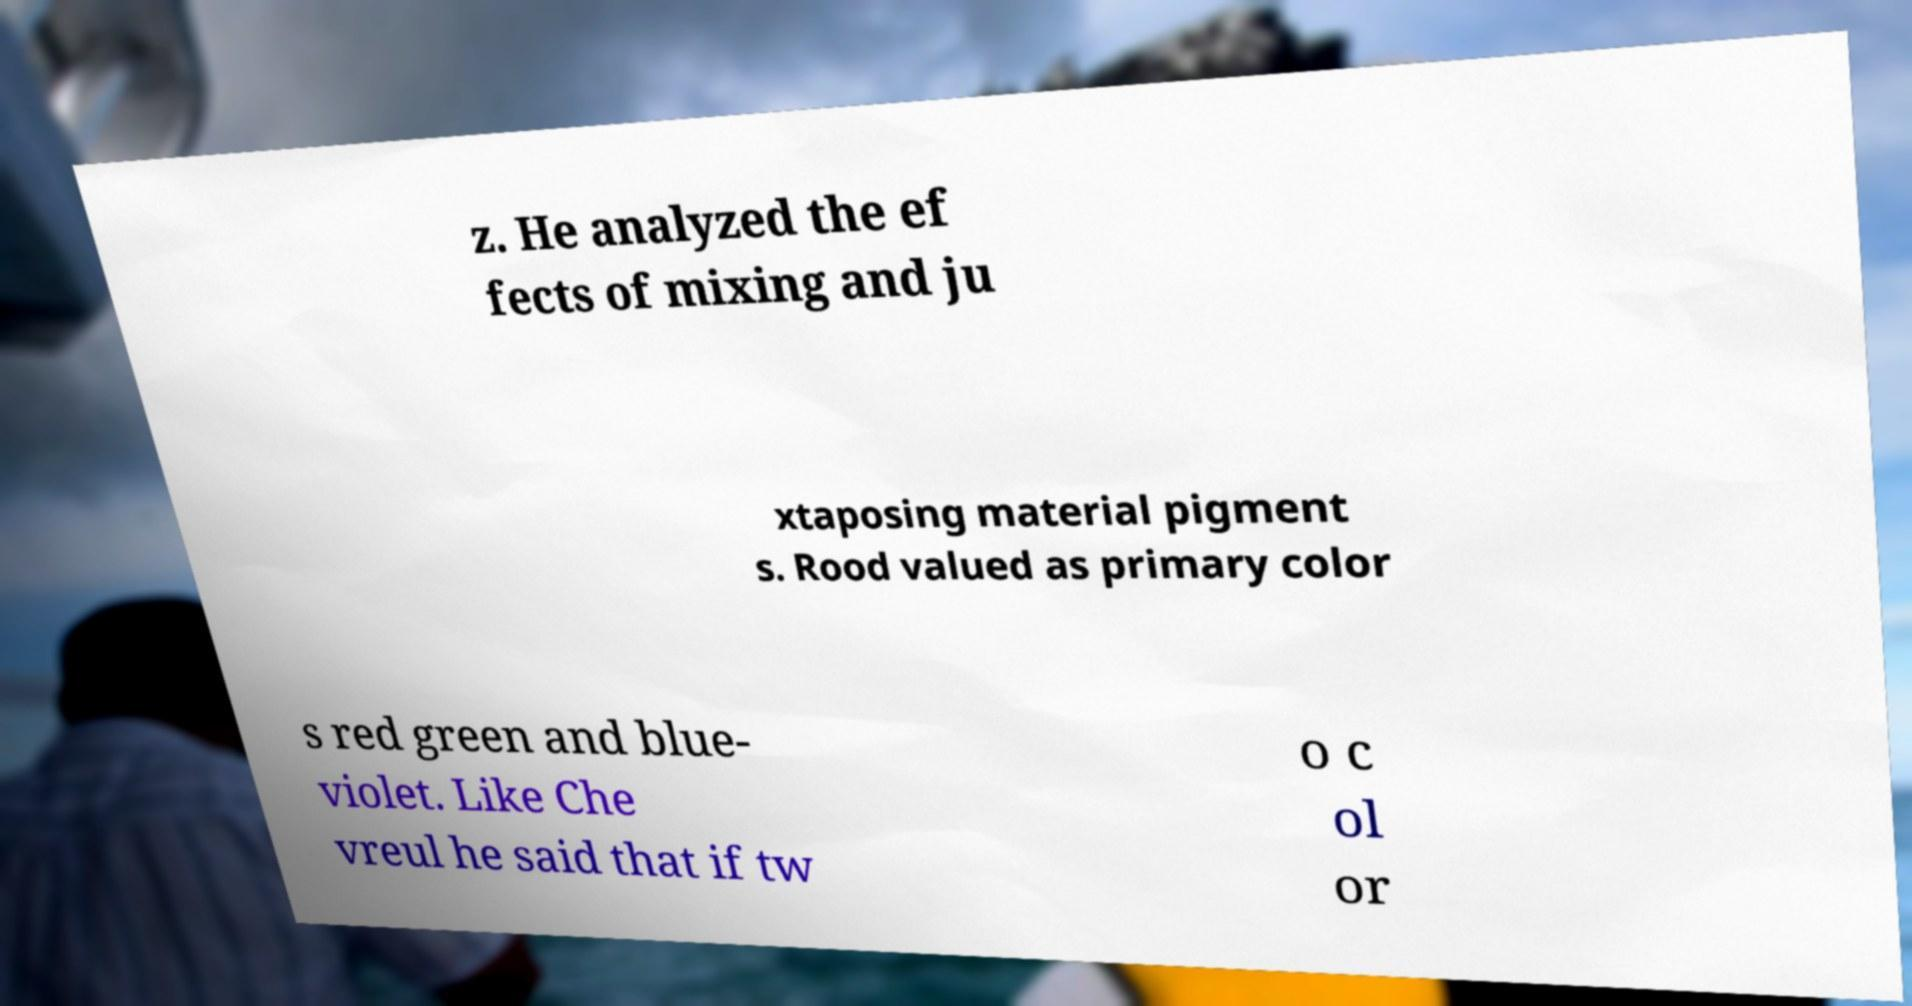I need the written content from this picture converted into text. Can you do that? z. He analyzed the ef fects of mixing and ju xtaposing material pigment s. Rood valued as primary color s red green and blue- violet. Like Che vreul he said that if tw o c ol or 